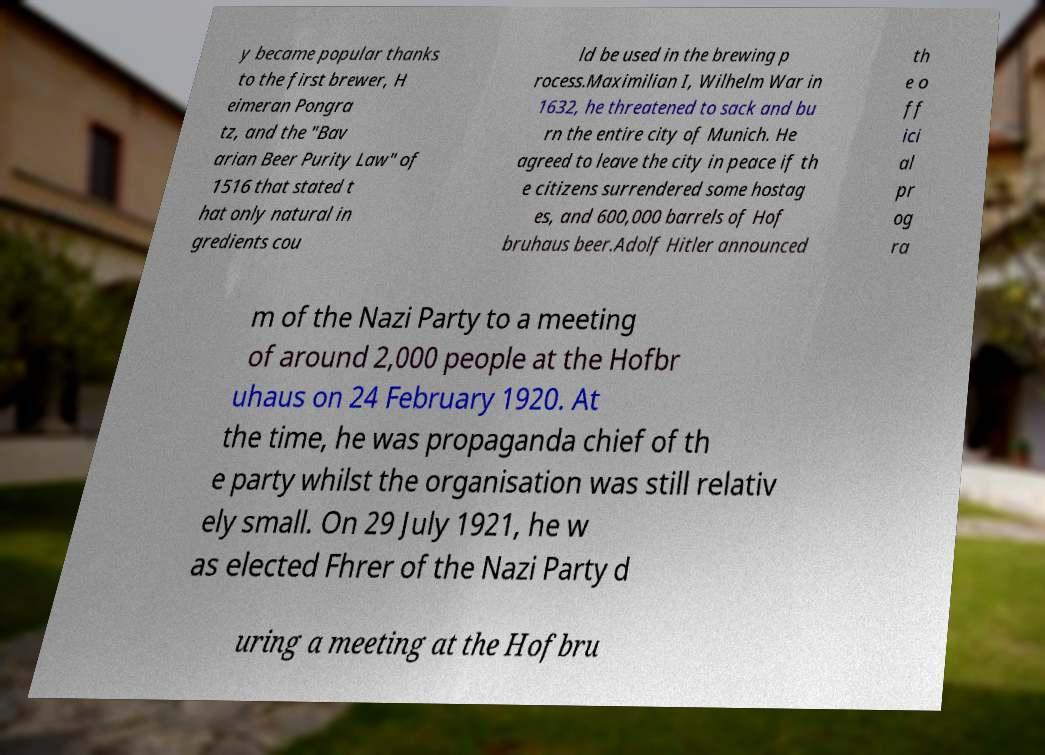Could you assist in decoding the text presented in this image and type it out clearly? y became popular thanks to the first brewer, H eimeran Pongra tz, and the "Bav arian Beer Purity Law" of 1516 that stated t hat only natural in gredients cou ld be used in the brewing p rocess.Maximilian I, Wilhelm War in 1632, he threatened to sack and bu rn the entire city of Munich. He agreed to leave the city in peace if th e citizens surrendered some hostag es, and 600,000 barrels of Hof bruhaus beer.Adolf Hitler announced th e o ff ici al pr og ra m of the Nazi Party to a meeting of around 2,000 people at the Hofbr uhaus on 24 February 1920. At the time, he was propaganda chief of th e party whilst the organisation was still relativ ely small. On 29 July 1921, he w as elected Fhrer of the Nazi Party d uring a meeting at the Hofbru 